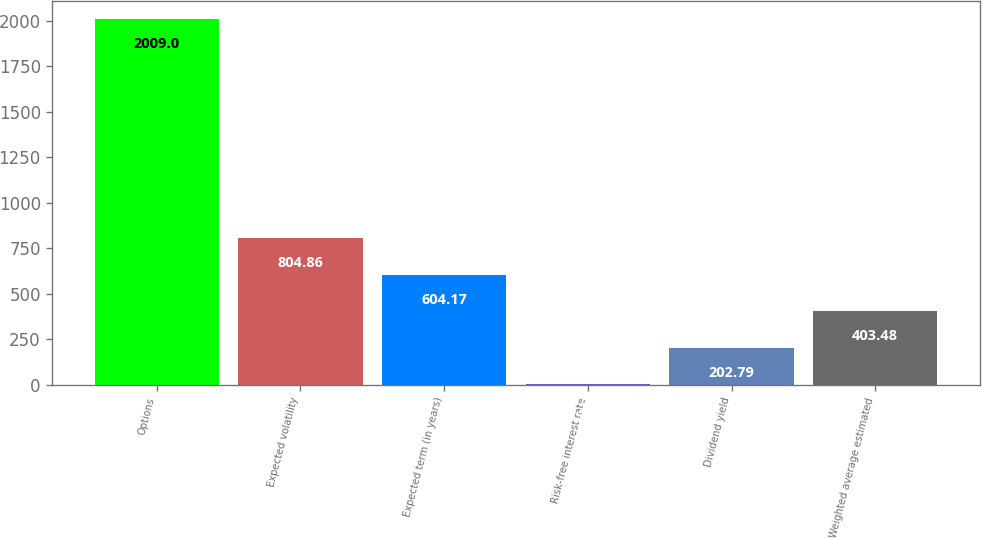<chart> <loc_0><loc_0><loc_500><loc_500><bar_chart><fcel>Options<fcel>Expected volatility<fcel>Expected term (in years)<fcel>Risk-free interest rate<fcel>Dividend yield<fcel>Weighted average estimated<nl><fcel>2009<fcel>804.86<fcel>604.17<fcel>2.1<fcel>202.79<fcel>403.48<nl></chart> 